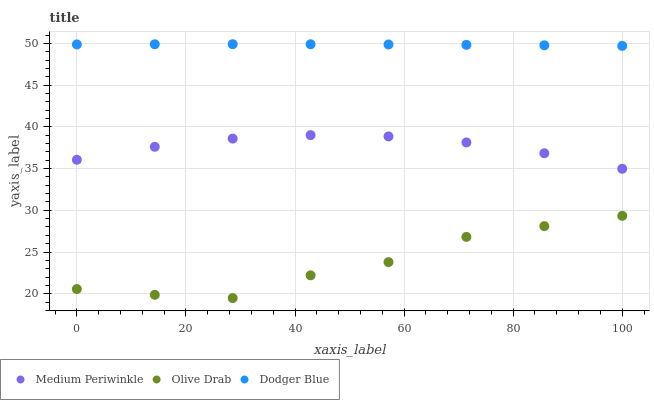Does Olive Drab have the minimum area under the curve?
Answer yes or no. Yes. Does Dodger Blue have the maximum area under the curve?
Answer yes or no. Yes. Does Medium Periwinkle have the minimum area under the curve?
Answer yes or no. No. Does Medium Periwinkle have the maximum area under the curve?
Answer yes or no. No. Is Dodger Blue the smoothest?
Answer yes or no. Yes. Is Olive Drab the roughest?
Answer yes or no. Yes. Is Medium Periwinkle the smoothest?
Answer yes or no. No. Is Medium Periwinkle the roughest?
Answer yes or no. No. Does Olive Drab have the lowest value?
Answer yes or no. Yes. Does Medium Periwinkle have the lowest value?
Answer yes or no. No. Does Dodger Blue have the highest value?
Answer yes or no. Yes. Does Medium Periwinkle have the highest value?
Answer yes or no. No. Is Medium Periwinkle less than Dodger Blue?
Answer yes or no. Yes. Is Medium Periwinkle greater than Olive Drab?
Answer yes or no. Yes. Does Medium Periwinkle intersect Dodger Blue?
Answer yes or no. No. 